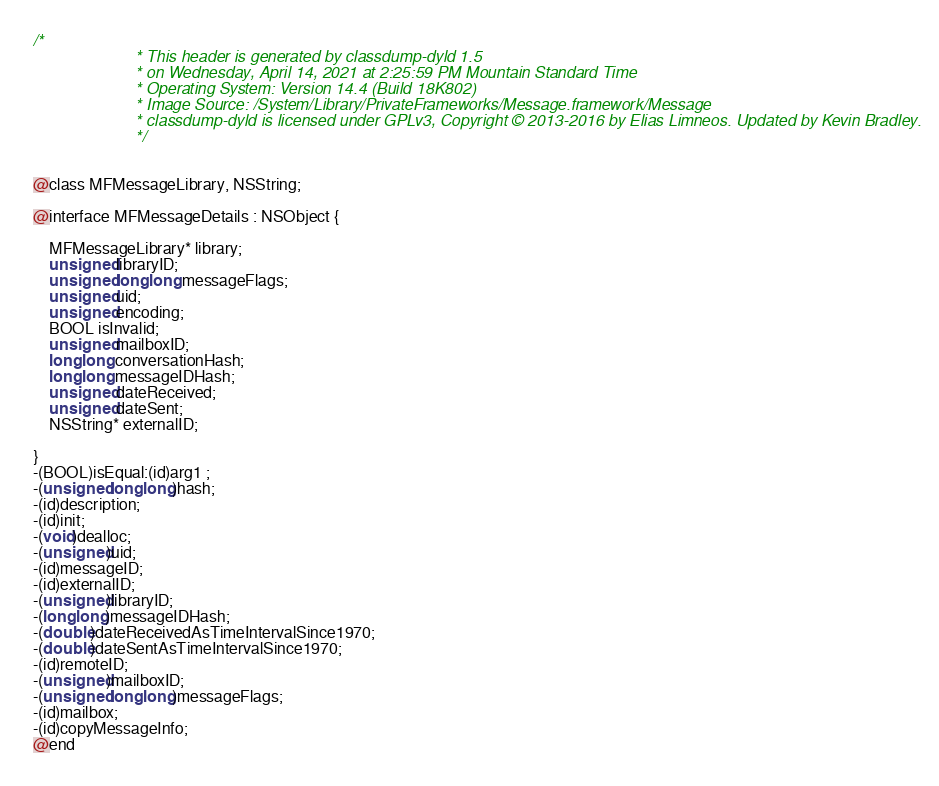<code> <loc_0><loc_0><loc_500><loc_500><_C_>/*
                       * This header is generated by classdump-dyld 1.5
                       * on Wednesday, April 14, 2021 at 2:25:59 PM Mountain Standard Time
                       * Operating System: Version 14.4 (Build 18K802)
                       * Image Source: /System/Library/PrivateFrameworks/Message.framework/Message
                       * classdump-dyld is licensed under GPLv3, Copyright © 2013-2016 by Elias Limneos. Updated by Kevin Bradley.
                       */


@class MFMessageLibrary, NSString;

@interface MFMessageDetails : NSObject {

	MFMessageLibrary* library;
	unsigned libraryID;
	unsigned long long messageFlags;
	unsigned uid;
	unsigned encoding;
	BOOL isInvalid;
	unsigned mailboxID;
	long long conversationHash;
	long long messageIDHash;
	unsigned dateReceived;
	unsigned dateSent;
	NSString* externalID;

}
-(BOOL)isEqual:(id)arg1 ;
-(unsigned long long)hash;
-(id)description;
-(id)init;
-(void)dealloc;
-(unsigned)uid;
-(id)messageID;
-(id)externalID;
-(unsigned)libraryID;
-(long long)messageIDHash;
-(double)dateReceivedAsTimeIntervalSince1970;
-(double)dateSentAsTimeIntervalSince1970;
-(id)remoteID;
-(unsigned)mailboxID;
-(unsigned long long)messageFlags;
-(id)mailbox;
-(id)copyMessageInfo;
@end

</code> 